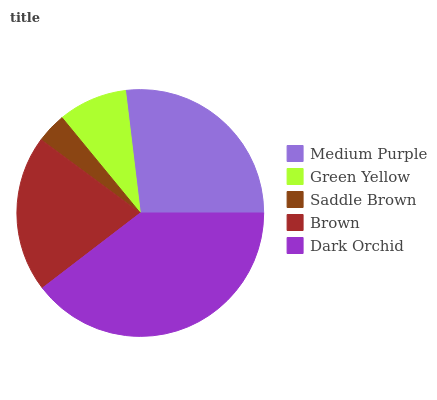Is Saddle Brown the minimum?
Answer yes or no. Yes. Is Dark Orchid the maximum?
Answer yes or no. Yes. Is Green Yellow the minimum?
Answer yes or no. No. Is Green Yellow the maximum?
Answer yes or no. No. Is Medium Purple greater than Green Yellow?
Answer yes or no. Yes. Is Green Yellow less than Medium Purple?
Answer yes or no. Yes. Is Green Yellow greater than Medium Purple?
Answer yes or no. No. Is Medium Purple less than Green Yellow?
Answer yes or no. No. Is Brown the high median?
Answer yes or no. Yes. Is Brown the low median?
Answer yes or no. Yes. Is Medium Purple the high median?
Answer yes or no. No. Is Saddle Brown the low median?
Answer yes or no. No. 